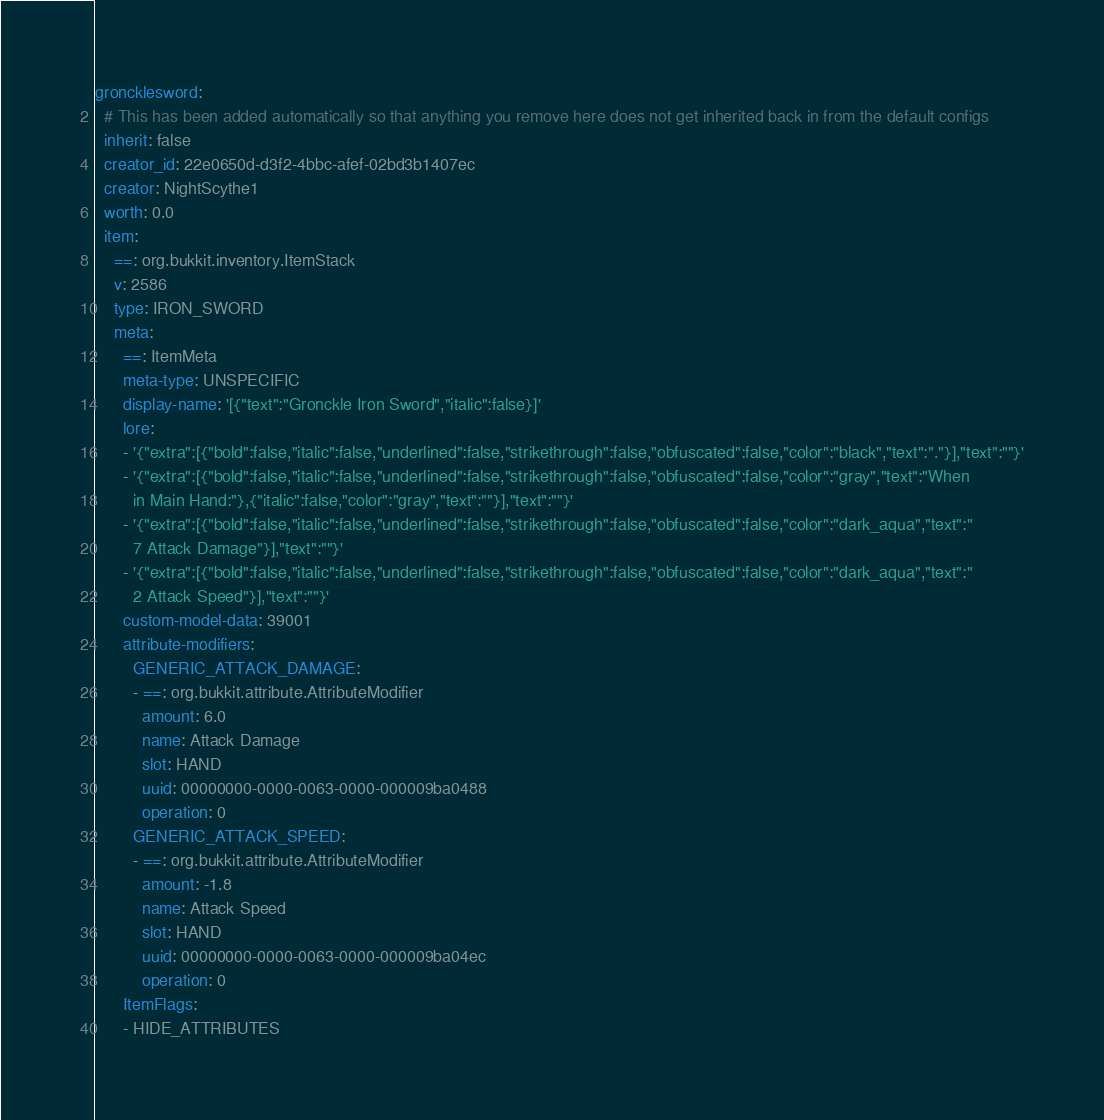<code> <loc_0><loc_0><loc_500><loc_500><_YAML_>groncklesword:
  # This has been added automatically so that anything you remove here does not get inherited back in from the default configs
  inherit: false
  creator_id: 22e0650d-d3f2-4bbc-afef-02bd3b1407ec
  creator: NightScythe1
  worth: 0.0
  item:
    ==: org.bukkit.inventory.ItemStack
    v: 2586
    type: IRON_SWORD
    meta:
      ==: ItemMeta
      meta-type: UNSPECIFIC
      display-name: '[{"text":"Gronckle Iron Sword","italic":false}]'
      lore:
      - '{"extra":[{"bold":false,"italic":false,"underlined":false,"strikethrough":false,"obfuscated":false,"color":"black","text":"."}],"text":""}'
      - '{"extra":[{"bold":false,"italic":false,"underlined":false,"strikethrough":false,"obfuscated":false,"color":"gray","text":"When
        in Main Hand:"},{"italic":false,"color":"gray","text":""}],"text":""}'
      - '{"extra":[{"bold":false,"italic":false,"underlined":false,"strikethrough":false,"obfuscated":false,"color":"dark_aqua","text":"
        7 Attack Damage"}],"text":""}'
      - '{"extra":[{"bold":false,"italic":false,"underlined":false,"strikethrough":false,"obfuscated":false,"color":"dark_aqua","text":"
        2 Attack Speed"}],"text":""}'
      custom-model-data: 39001
      attribute-modifiers:
        GENERIC_ATTACK_DAMAGE:
        - ==: org.bukkit.attribute.AttributeModifier
          amount: 6.0
          name: Attack Damage
          slot: HAND
          uuid: 00000000-0000-0063-0000-000009ba0488
          operation: 0
        GENERIC_ATTACK_SPEED:
        - ==: org.bukkit.attribute.AttributeModifier
          amount: -1.8
          name: Attack Speed
          slot: HAND
          uuid: 00000000-0000-0063-0000-000009ba04ec
          operation: 0
      ItemFlags:
      - HIDE_ATTRIBUTES</code> 